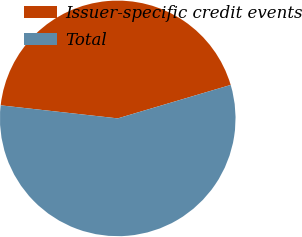Convert chart. <chart><loc_0><loc_0><loc_500><loc_500><pie_chart><fcel>Issuer-specific credit events<fcel>Total<nl><fcel>43.65%<fcel>56.35%<nl></chart> 